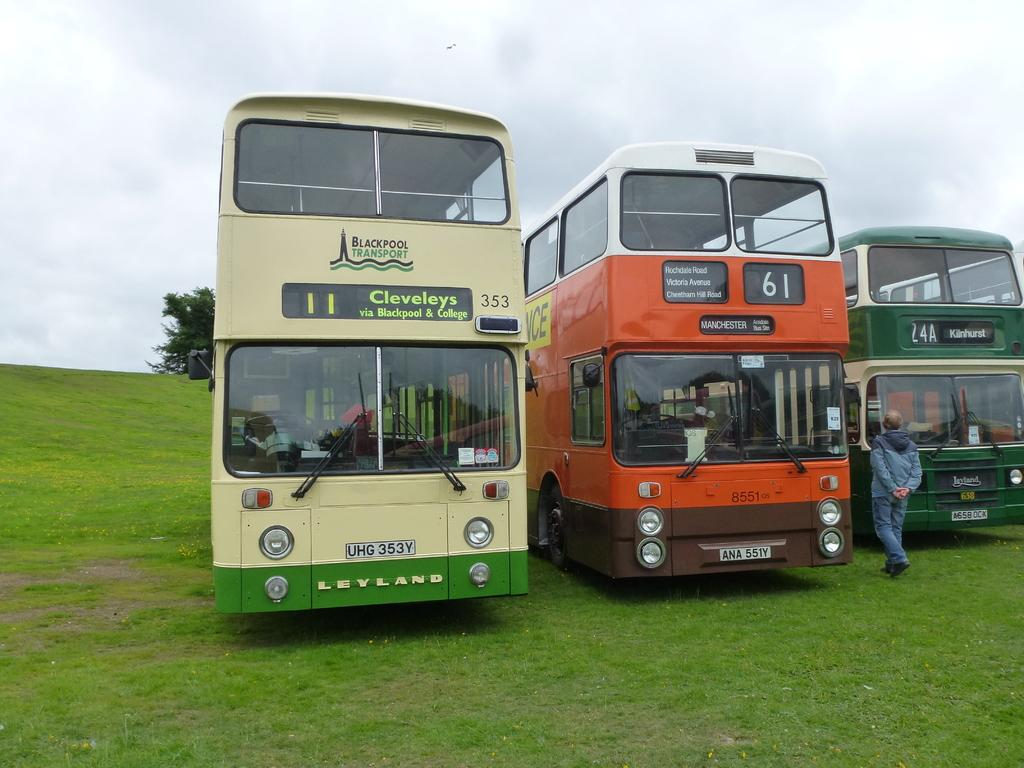What type of vehicles are on the ground in the image? There are buses on the ground in the image. Can you describe the person near the buses? A person is standing near the buses. What can be seen in the background of the image? There is a tree and the sky visible in the background of the image. What is the condition of the sky in the image? Clouds are present in the sky. What type of cheese is being served by the person's mom in the image? There is no cheese or person's mom present in the image. Can you tell me how many boats are docked at the harbor in the image? There is no harbor or boats present in the image. 